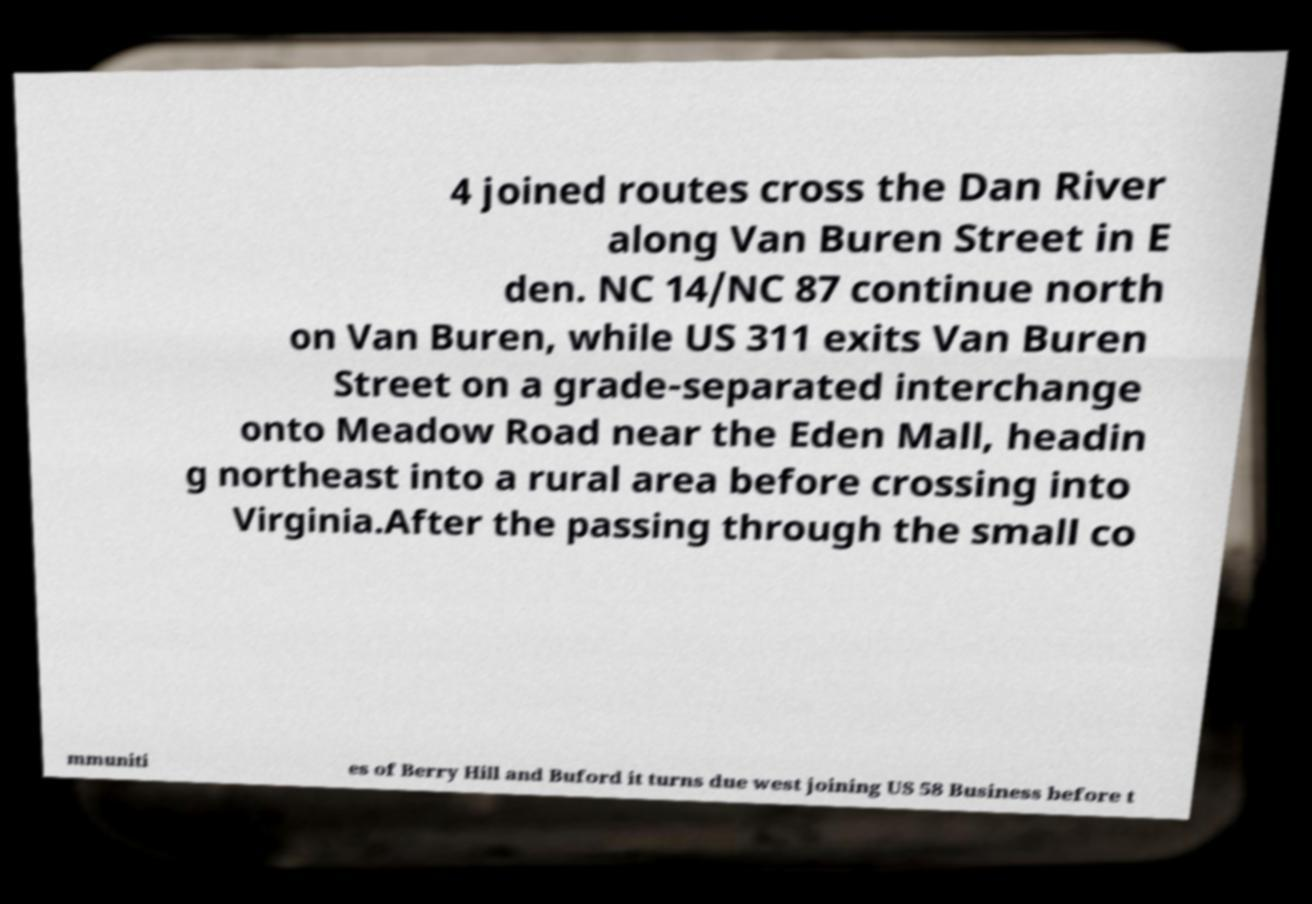Can you read and provide the text displayed in the image?This photo seems to have some interesting text. Can you extract and type it out for me? 4 joined routes cross the Dan River along Van Buren Street in E den. NC 14/NC 87 continue north on Van Buren, while US 311 exits Van Buren Street on a grade-separated interchange onto Meadow Road near the Eden Mall, headin g northeast into a rural area before crossing into Virginia.After the passing through the small co mmuniti es of Berry Hill and Buford it turns due west joining US 58 Business before t 